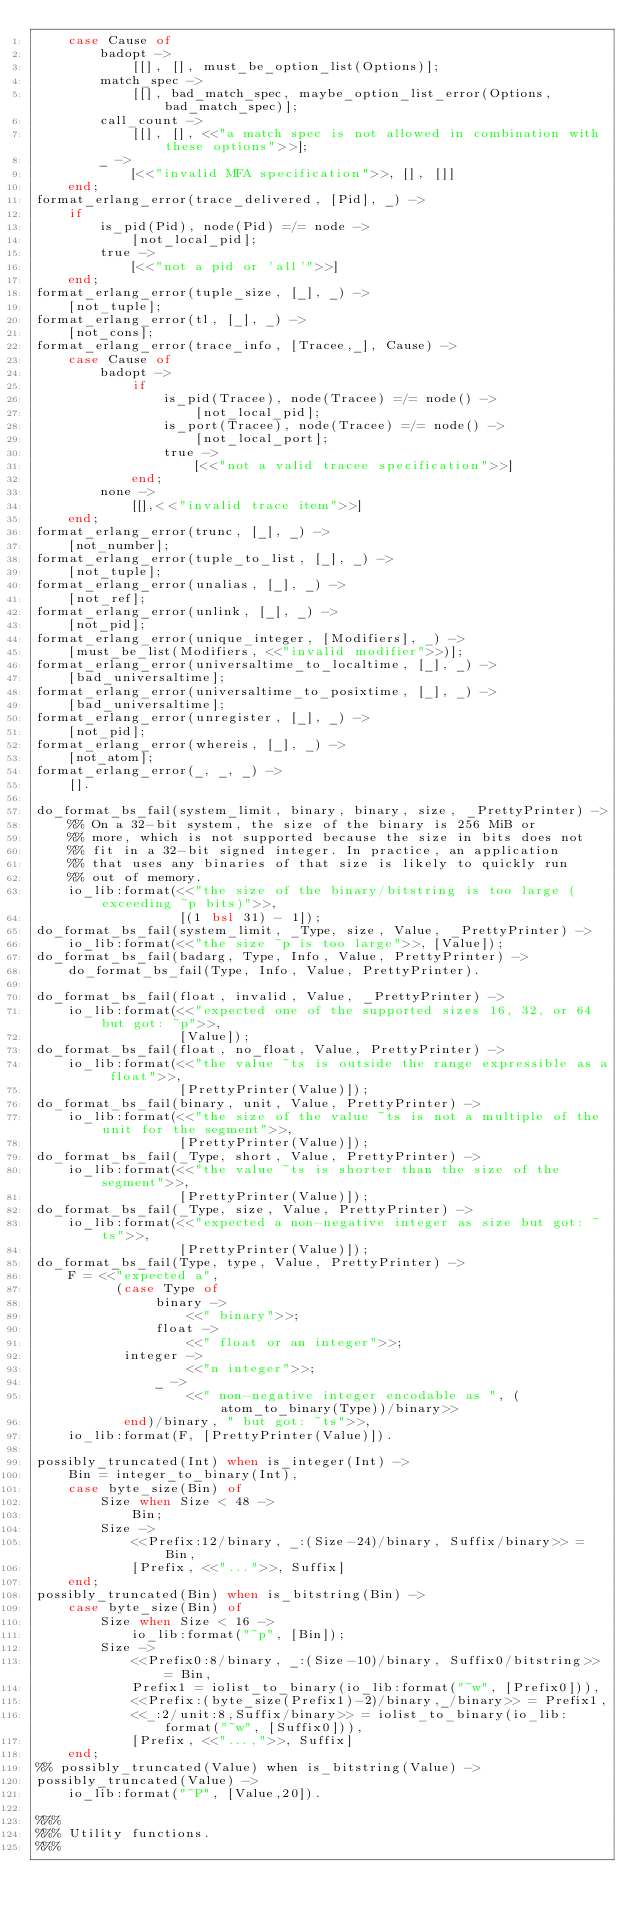Convert code to text. <code><loc_0><loc_0><loc_500><loc_500><_Erlang_>    case Cause of
        badopt ->
            [[], [], must_be_option_list(Options)];
        match_spec ->
            [[], bad_match_spec, maybe_option_list_error(Options, bad_match_spec)];
        call_count ->
            [[], [], <<"a match spec is not allowed in combination with these options">>];
        _ ->
            [<<"invalid MFA specification">>, [], []]
    end;
format_erlang_error(trace_delivered, [Pid], _) ->
    if
        is_pid(Pid), node(Pid) =/= node ->
            [not_local_pid];
        true ->
            [<<"not a pid or 'all'">>]
    end;
format_erlang_error(tuple_size, [_], _) ->
    [not_tuple];
format_erlang_error(tl, [_], _) ->
    [not_cons];
format_erlang_error(trace_info, [Tracee,_], Cause) ->
    case Cause of
        badopt ->
            if
                is_pid(Tracee), node(Tracee) =/= node() ->
                    [not_local_pid];
                is_port(Tracee), node(Tracee) =/= node() ->
                    [not_local_port];
                true ->
                    [<<"not a valid tracee specification">>]
            end;
        none ->
            [[],<<"invalid trace item">>]
    end;
format_erlang_error(trunc, [_], _) ->
    [not_number];
format_erlang_error(tuple_to_list, [_], _) ->
    [not_tuple];
format_erlang_error(unalias, [_], _) ->
    [not_ref];
format_erlang_error(unlink, [_], _) ->
    [not_pid];
format_erlang_error(unique_integer, [Modifiers], _) ->
    [must_be_list(Modifiers, <<"invalid modifier">>)];
format_erlang_error(universaltime_to_localtime, [_], _) ->
    [bad_universaltime];
format_erlang_error(universaltime_to_posixtime, [_], _) ->
    [bad_universaltime];
format_erlang_error(unregister, [_], _) ->
    [not_pid];
format_erlang_error(whereis, [_], _) ->
    [not_atom];
format_erlang_error(_, _, _) ->
    [].

do_format_bs_fail(system_limit, binary, binary, size, _PrettyPrinter) ->
    %% On a 32-bit system, the size of the binary is 256 MiB or
    %% more, which is not supported because the size in bits does not
    %% fit in a 32-bit signed integer. In practice, an application
    %% that uses any binaries of that size is likely to quickly run
    %% out of memory.
    io_lib:format(<<"the size of the binary/bitstring is too large (exceeding ~p bits)">>,
                  [(1 bsl 31) - 1]);
do_format_bs_fail(system_limit, _Type, size, Value, _PrettyPrinter) ->
    io_lib:format(<<"the size ~p is too large">>, [Value]);
do_format_bs_fail(badarg, Type, Info, Value, PrettyPrinter) ->
    do_format_bs_fail(Type, Info, Value, PrettyPrinter).

do_format_bs_fail(float, invalid, Value, _PrettyPrinter) ->
    io_lib:format(<<"expected one of the supported sizes 16, 32, or 64 but got: ~p">>,
                  [Value]);
do_format_bs_fail(float, no_float, Value, PrettyPrinter) ->
    io_lib:format(<<"the value ~ts is outside the range expressible as a float">>,
                  [PrettyPrinter(Value)]);
do_format_bs_fail(binary, unit, Value, PrettyPrinter) ->
    io_lib:format(<<"the size of the value ~ts is not a multiple of the unit for the segment">>,
                  [PrettyPrinter(Value)]);
do_format_bs_fail(_Type, short, Value, PrettyPrinter) ->
    io_lib:format(<<"the value ~ts is shorter than the size of the segment">>,
                  [PrettyPrinter(Value)]);
do_format_bs_fail(_Type, size, Value, PrettyPrinter) ->
    io_lib:format(<<"expected a non-negative integer as size but got: ~ts">>,
                  [PrettyPrinter(Value)]);
do_format_bs_fail(Type, type, Value, PrettyPrinter) ->
    F = <<"expected a",
          (case Type of
               binary ->
                   <<" binary">>;
               float ->
                   <<" float or an integer">>;
           integer ->
                   <<"n integer">>;
               _ ->
                   <<" non-negative integer encodable as ", (atom_to_binary(Type))/binary>>
           end)/binary, " but got: ~ts">>,
    io_lib:format(F, [PrettyPrinter(Value)]).

possibly_truncated(Int) when is_integer(Int) ->
    Bin = integer_to_binary(Int),
    case byte_size(Bin) of
        Size when Size < 48 ->
            Bin;
        Size ->
            <<Prefix:12/binary, _:(Size-24)/binary, Suffix/binary>> = Bin,
            [Prefix, <<"...">>, Suffix]
    end;
possibly_truncated(Bin) when is_bitstring(Bin) ->
    case byte_size(Bin) of
        Size when Size < 16 ->
            io_lib:format("~p", [Bin]);
        Size ->
            <<Prefix0:8/binary, _:(Size-10)/binary, Suffix0/bitstring>> = Bin,
            Prefix1 = iolist_to_binary(io_lib:format("~w", [Prefix0])),
            <<Prefix:(byte_size(Prefix1)-2)/binary,_/binary>> = Prefix1,
            <<_:2/unit:8,Suffix/binary>> = iolist_to_binary(io_lib:format("~w", [Suffix0])),
            [Prefix, <<"...,">>, Suffix]
    end;
%% possibly_truncated(Value) when is_bitstring(Value) ->
possibly_truncated(Value) ->
    io_lib:format("~P", [Value,20]).

%%%
%%% Utility functions.
%%%
</code> 